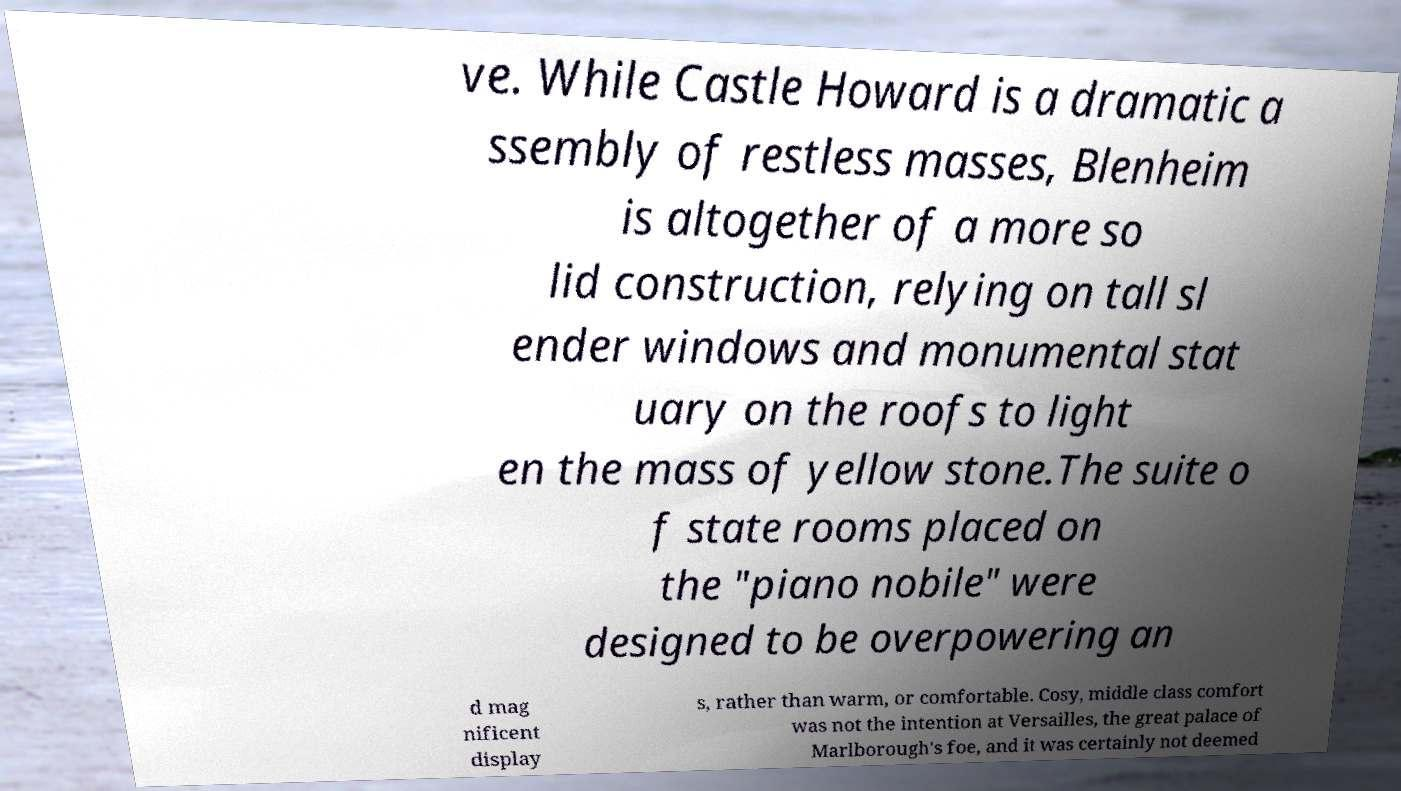Can you accurately transcribe the text from the provided image for me? ve. While Castle Howard is a dramatic a ssembly of restless masses, Blenheim is altogether of a more so lid construction, relying on tall sl ender windows and monumental stat uary on the roofs to light en the mass of yellow stone.The suite o f state rooms placed on the "piano nobile" were designed to be overpowering an d mag nificent display s, rather than warm, or comfortable. Cosy, middle class comfort was not the intention at Versailles, the great palace of Marlborough's foe, and it was certainly not deemed 